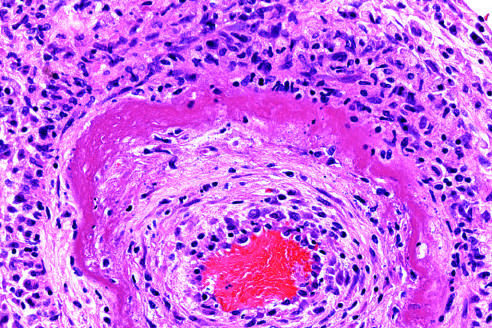how does the wall of the artery show a circumferential bright pink area of necrosis?
Answer the question using a single word or phrase. With protein deposition and inflammation 